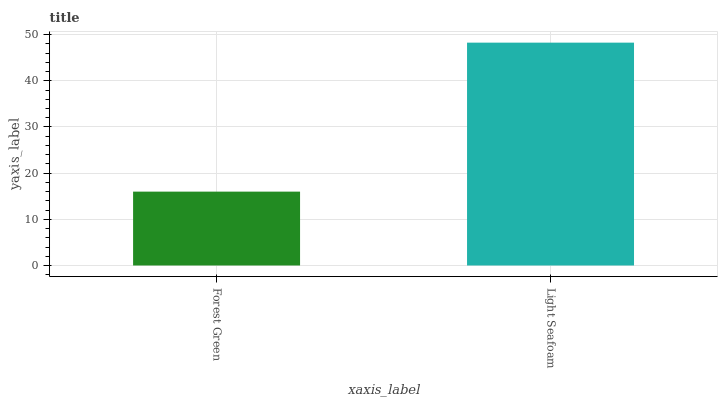Is Forest Green the minimum?
Answer yes or no. Yes. Is Light Seafoam the maximum?
Answer yes or no. Yes. Is Light Seafoam the minimum?
Answer yes or no. No. Is Light Seafoam greater than Forest Green?
Answer yes or no. Yes. Is Forest Green less than Light Seafoam?
Answer yes or no. Yes. Is Forest Green greater than Light Seafoam?
Answer yes or no. No. Is Light Seafoam less than Forest Green?
Answer yes or no. No. Is Light Seafoam the high median?
Answer yes or no. Yes. Is Forest Green the low median?
Answer yes or no. Yes. Is Forest Green the high median?
Answer yes or no. No. Is Light Seafoam the low median?
Answer yes or no. No. 